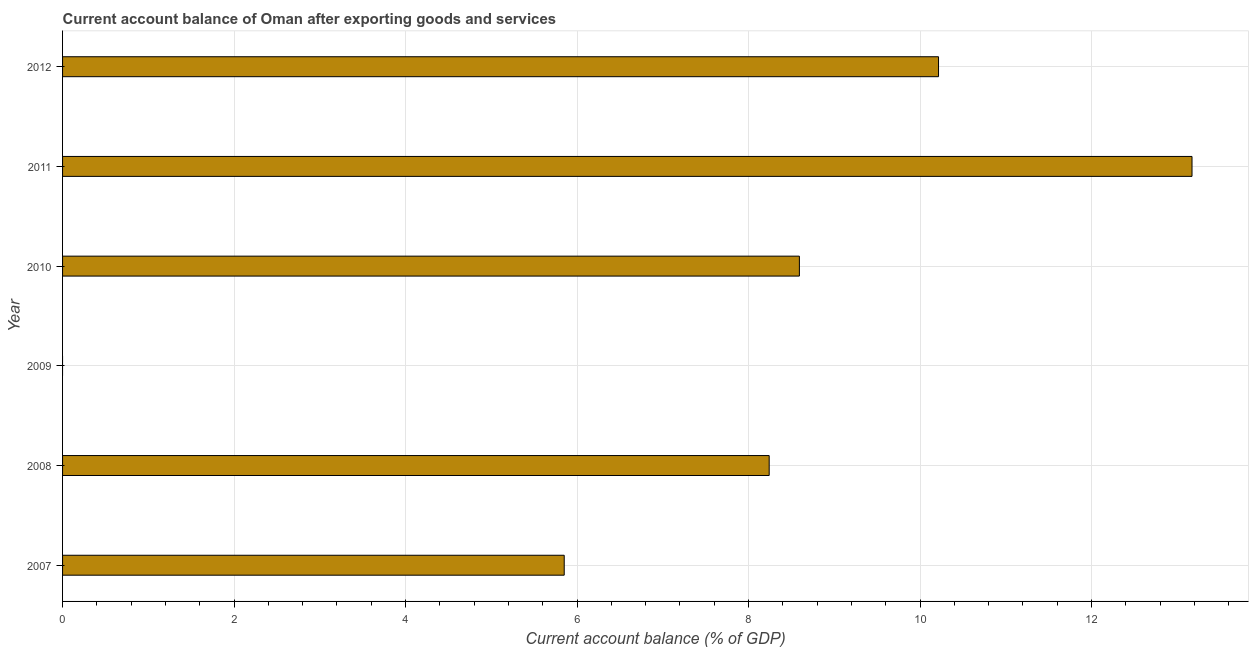Does the graph contain grids?
Keep it short and to the point. Yes. What is the title of the graph?
Provide a short and direct response. Current account balance of Oman after exporting goods and services. What is the label or title of the X-axis?
Your answer should be very brief. Current account balance (% of GDP). What is the current account balance in 2008?
Keep it short and to the point. 8.24. Across all years, what is the maximum current account balance?
Ensure brevity in your answer.  13.17. In which year was the current account balance maximum?
Your response must be concise. 2011. What is the sum of the current account balance?
Keep it short and to the point. 46.07. What is the difference between the current account balance in 2008 and 2011?
Offer a very short reply. -4.93. What is the average current account balance per year?
Make the answer very short. 7.68. What is the median current account balance?
Provide a short and direct response. 8.42. In how many years, is the current account balance greater than 5.6 %?
Make the answer very short. 5. What is the ratio of the current account balance in 2010 to that in 2011?
Your response must be concise. 0.65. Is the current account balance in 2010 less than that in 2012?
Your answer should be compact. Yes. What is the difference between the highest and the second highest current account balance?
Offer a very short reply. 2.96. What is the difference between the highest and the lowest current account balance?
Provide a short and direct response. 13.17. In how many years, is the current account balance greater than the average current account balance taken over all years?
Ensure brevity in your answer.  4. How many bars are there?
Offer a very short reply. 5. Are all the bars in the graph horizontal?
Make the answer very short. Yes. How many years are there in the graph?
Your answer should be compact. 6. What is the difference between two consecutive major ticks on the X-axis?
Make the answer very short. 2. Are the values on the major ticks of X-axis written in scientific E-notation?
Keep it short and to the point. No. What is the Current account balance (% of GDP) of 2007?
Make the answer very short. 5.85. What is the Current account balance (% of GDP) in 2008?
Provide a succinct answer. 8.24. What is the Current account balance (% of GDP) of 2009?
Ensure brevity in your answer.  0. What is the Current account balance (% of GDP) in 2010?
Make the answer very short. 8.59. What is the Current account balance (% of GDP) in 2011?
Provide a short and direct response. 13.17. What is the Current account balance (% of GDP) in 2012?
Ensure brevity in your answer.  10.22. What is the difference between the Current account balance (% of GDP) in 2007 and 2008?
Make the answer very short. -2.39. What is the difference between the Current account balance (% of GDP) in 2007 and 2010?
Your response must be concise. -2.74. What is the difference between the Current account balance (% of GDP) in 2007 and 2011?
Keep it short and to the point. -7.32. What is the difference between the Current account balance (% of GDP) in 2007 and 2012?
Offer a very short reply. -4.37. What is the difference between the Current account balance (% of GDP) in 2008 and 2010?
Your response must be concise. -0.35. What is the difference between the Current account balance (% of GDP) in 2008 and 2011?
Keep it short and to the point. -4.93. What is the difference between the Current account balance (% of GDP) in 2008 and 2012?
Provide a succinct answer. -1.97. What is the difference between the Current account balance (% of GDP) in 2010 and 2011?
Your answer should be compact. -4.58. What is the difference between the Current account balance (% of GDP) in 2010 and 2012?
Your answer should be very brief. -1.62. What is the difference between the Current account balance (% of GDP) in 2011 and 2012?
Your response must be concise. 2.96. What is the ratio of the Current account balance (% of GDP) in 2007 to that in 2008?
Make the answer very short. 0.71. What is the ratio of the Current account balance (% of GDP) in 2007 to that in 2010?
Your answer should be very brief. 0.68. What is the ratio of the Current account balance (% of GDP) in 2007 to that in 2011?
Offer a terse response. 0.44. What is the ratio of the Current account balance (% of GDP) in 2007 to that in 2012?
Offer a terse response. 0.57. What is the ratio of the Current account balance (% of GDP) in 2008 to that in 2010?
Keep it short and to the point. 0.96. What is the ratio of the Current account balance (% of GDP) in 2008 to that in 2011?
Offer a terse response. 0.63. What is the ratio of the Current account balance (% of GDP) in 2008 to that in 2012?
Provide a short and direct response. 0.81. What is the ratio of the Current account balance (% of GDP) in 2010 to that in 2011?
Provide a succinct answer. 0.65. What is the ratio of the Current account balance (% of GDP) in 2010 to that in 2012?
Your answer should be very brief. 0.84. What is the ratio of the Current account balance (% of GDP) in 2011 to that in 2012?
Provide a succinct answer. 1.29. 